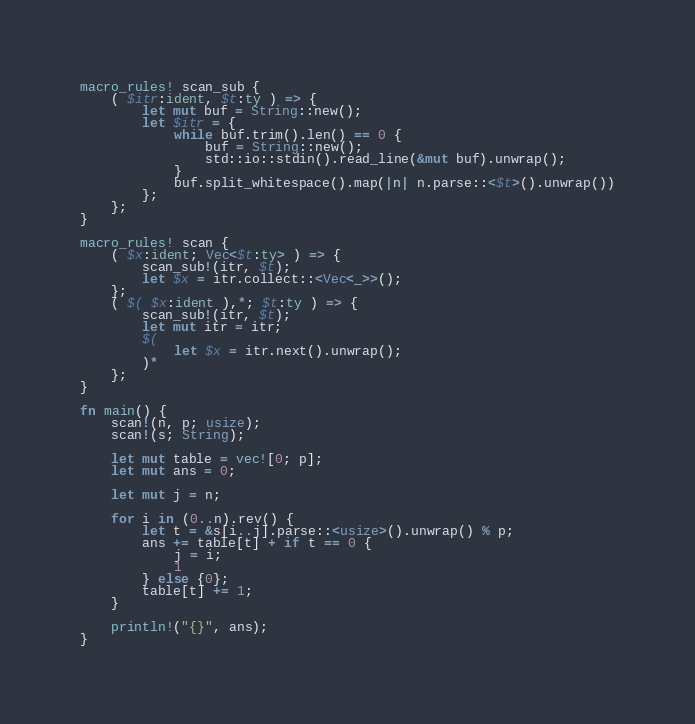<code> <loc_0><loc_0><loc_500><loc_500><_Rust_>macro_rules! scan_sub {
    ( $itr:ident, $t:ty ) => {
        let mut buf = String::new();
        let $itr = {
            while buf.trim().len() == 0 {
                buf = String::new();
                std::io::stdin().read_line(&mut buf).unwrap();
            }
            buf.split_whitespace().map(|n| n.parse::<$t>().unwrap())
        };
    };
}

macro_rules! scan {
    ( $x:ident; Vec<$t:ty> ) => {
        scan_sub!(itr, $t);
        let $x = itr.collect::<Vec<_>>();
    };
    ( $( $x:ident ),*; $t:ty ) => {
        scan_sub!(itr, $t);
        let mut itr = itr;
        $(
            let $x = itr.next().unwrap();
        )*
    };
}

fn main() {
    scan!(n, p; usize);
    scan!(s; String);

    let mut table = vec![0; p];
    let mut ans = 0;

    let mut j = n;

    for i in (0..n).rev() {
        let t = &s[i..j].parse::<usize>().unwrap() % p;
        ans += table[t] + if t == 0 {
            j = i;
            1
        } else {0};
        table[t] += 1;
    }

    println!("{}", ans);
}
</code> 